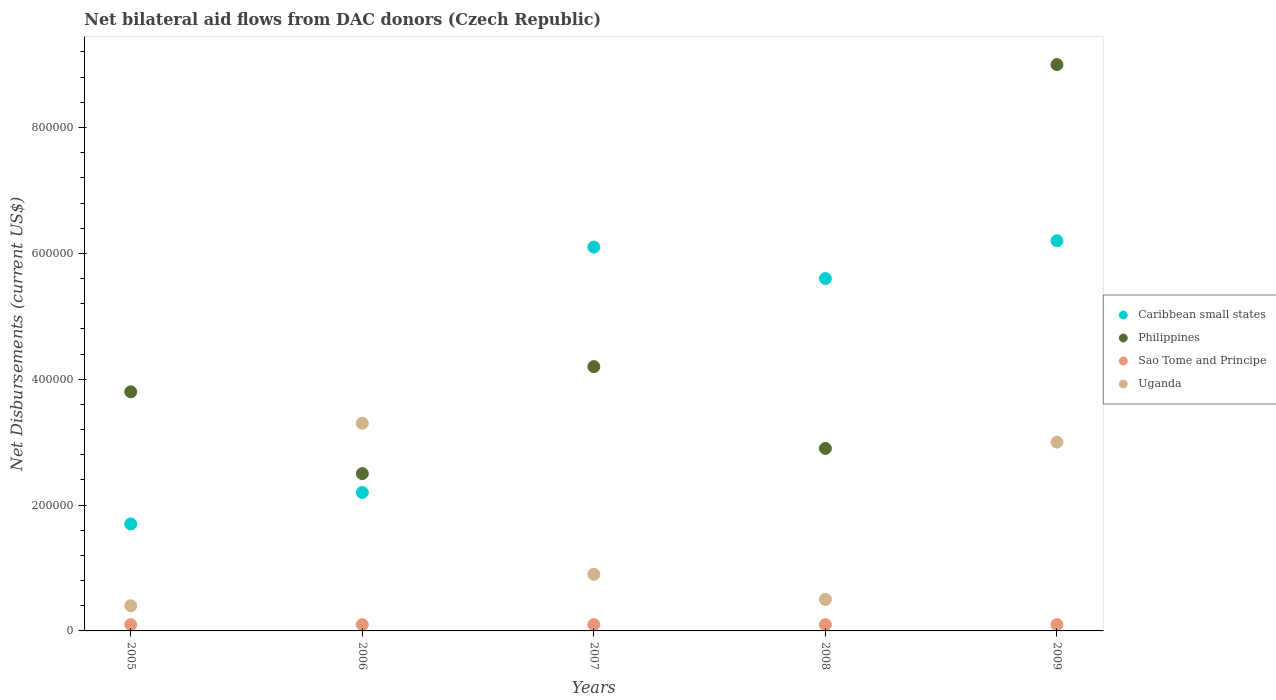How many different coloured dotlines are there?
Ensure brevity in your answer.  4. Is the number of dotlines equal to the number of legend labels?
Provide a short and direct response. Yes. What is the net bilateral aid flows in Philippines in 2008?
Ensure brevity in your answer.  2.90e+05. Across all years, what is the maximum net bilateral aid flows in Philippines?
Provide a short and direct response. 9.00e+05. Across all years, what is the minimum net bilateral aid flows in Caribbean small states?
Your response must be concise. 1.70e+05. What is the total net bilateral aid flows in Uganda in the graph?
Provide a succinct answer. 8.10e+05. What is the difference between the net bilateral aid flows in Caribbean small states in 2007 and that in 2008?
Offer a very short reply. 5.00e+04. What is the difference between the net bilateral aid flows in Philippines in 2006 and the net bilateral aid flows in Uganda in 2007?
Offer a terse response. 1.60e+05. What is the average net bilateral aid flows in Philippines per year?
Offer a terse response. 4.48e+05. Is the net bilateral aid flows in Sao Tome and Principe in 2006 less than that in 2007?
Your response must be concise. No. What is the difference between the highest and the second highest net bilateral aid flows in Sao Tome and Principe?
Your answer should be very brief. 0. What is the difference between the highest and the lowest net bilateral aid flows in Uganda?
Provide a succinct answer. 2.90e+05. Is it the case that in every year, the sum of the net bilateral aid flows in Uganda and net bilateral aid flows in Philippines  is greater than the net bilateral aid flows in Sao Tome and Principe?
Ensure brevity in your answer.  Yes. How many dotlines are there?
Provide a short and direct response. 4. How many years are there in the graph?
Provide a short and direct response. 5. What is the difference between two consecutive major ticks on the Y-axis?
Make the answer very short. 2.00e+05. Does the graph contain grids?
Your answer should be compact. No. What is the title of the graph?
Your answer should be very brief. Net bilateral aid flows from DAC donors (Czech Republic). What is the label or title of the X-axis?
Provide a succinct answer. Years. What is the label or title of the Y-axis?
Keep it short and to the point. Net Disbursements (current US$). What is the Net Disbursements (current US$) of Caribbean small states in 2005?
Give a very brief answer. 1.70e+05. What is the Net Disbursements (current US$) in Philippines in 2005?
Give a very brief answer. 3.80e+05. What is the Net Disbursements (current US$) of Sao Tome and Principe in 2005?
Ensure brevity in your answer.  10000. What is the Net Disbursements (current US$) in Uganda in 2005?
Make the answer very short. 4.00e+04. What is the Net Disbursements (current US$) in Sao Tome and Principe in 2006?
Ensure brevity in your answer.  10000. What is the Net Disbursements (current US$) of Uganda in 2007?
Provide a short and direct response. 9.00e+04. What is the Net Disbursements (current US$) in Caribbean small states in 2008?
Give a very brief answer. 5.60e+05. What is the Net Disbursements (current US$) in Sao Tome and Principe in 2008?
Ensure brevity in your answer.  10000. What is the Net Disbursements (current US$) of Uganda in 2008?
Provide a succinct answer. 5.00e+04. What is the Net Disbursements (current US$) of Caribbean small states in 2009?
Offer a very short reply. 6.20e+05. What is the Net Disbursements (current US$) of Uganda in 2009?
Your answer should be compact. 3.00e+05. Across all years, what is the maximum Net Disbursements (current US$) in Caribbean small states?
Make the answer very short. 6.20e+05. Across all years, what is the maximum Net Disbursements (current US$) in Philippines?
Keep it short and to the point. 9.00e+05. Across all years, what is the maximum Net Disbursements (current US$) in Uganda?
Make the answer very short. 3.30e+05. Across all years, what is the minimum Net Disbursements (current US$) in Sao Tome and Principe?
Keep it short and to the point. 10000. What is the total Net Disbursements (current US$) in Caribbean small states in the graph?
Ensure brevity in your answer.  2.18e+06. What is the total Net Disbursements (current US$) of Philippines in the graph?
Your response must be concise. 2.24e+06. What is the total Net Disbursements (current US$) in Sao Tome and Principe in the graph?
Offer a very short reply. 5.00e+04. What is the total Net Disbursements (current US$) of Uganda in the graph?
Give a very brief answer. 8.10e+05. What is the difference between the Net Disbursements (current US$) in Caribbean small states in 2005 and that in 2007?
Make the answer very short. -4.40e+05. What is the difference between the Net Disbursements (current US$) of Philippines in 2005 and that in 2007?
Offer a very short reply. -4.00e+04. What is the difference between the Net Disbursements (current US$) in Sao Tome and Principe in 2005 and that in 2007?
Provide a succinct answer. 0. What is the difference between the Net Disbursements (current US$) of Uganda in 2005 and that in 2007?
Offer a very short reply. -5.00e+04. What is the difference between the Net Disbursements (current US$) of Caribbean small states in 2005 and that in 2008?
Provide a short and direct response. -3.90e+05. What is the difference between the Net Disbursements (current US$) in Philippines in 2005 and that in 2008?
Your answer should be compact. 9.00e+04. What is the difference between the Net Disbursements (current US$) of Sao Tome and Principe in 2005 and that in 2008?
Provide a succinct answer. 0. What is the difference between the Net Disbursements (current US$) of Uganda in 2005 and that in 2008?
Offer a very short reply. -10000. What is the difference between the Net Disbursements (current US$) of Caribbean small states in 2005 and that in 2009?
Provide a succinct answer. -4.50e+05. What is the difference between the Net Disbursements (current US$) of Philippines in 2005 and that in 2009?
Ensure brevity in your answer.  -5.20e+05. What is the difference between the Net Disbursements (current US$) of Sao Tome and Principe in 2005 and that in 2009?
Offer a terse response. 0. What is the difference between the Net Disbursements (current US$) of Uganda in 2005 and that in 2009?
Your answer should be compact. -2.60e+05. What is the difference between the Net Disbursements (current US$) in Caribbean small states in 2006 and that in 2007?
Make the answer very short. -3.90e+05. What is the difference between the Net Disbursements (current US$) of Philippines in 2006 and that in 2007?
Your response must be concise. -1.70e+05. What is the difference between the Net Disbursements (current US$) of Uganda in 2006 and that in 2007?
Your answer should be very brief. 2.40e+05. What is the difference between the Net Disbursements (current US$) of Philippines in 2006 and that in 2008?
Offer a terse response. -4.00e+04. What is the difference between the Net Disbursements (current US$) of Sao Tome and Principe in 2006 and that in 2008?
Provide a succinct answer. 0. What is the difference between the Net Disbursements (current US$) of Caribbean small states in 2006 and that in 2009?
Keep it short and to the point. -4.00e+05. What is the difference between the Net Disbursements (current US$) of Philippines in 2006 and that in 2009?
Keep it short and to the point. -6.50e+05. What is the difference between the Net Disbursements (current US$) of Philippines in 2007 and that in 2008?
Keep it short and to the point. 1.30e+05. What is the difference between the Net Disbursements (current US$) in Sao Tome and Principe in 2007 and that in 2008?
Provide a succinct answer. 0. What is the difference between the Net Disbursements (current US$) in Uganda in 2007 and that in 2008?
Ensure brevity in your answer.  4.00e+04. What is the difference between the Net Disbursements (current US$) of Philippines in 2007 and that in 2009?
Make the answer very short. -4.80e+05. What is the difference between the Net Disbursements (current US$) in Sao Tome and Principe in 2007 and that in 2009?
Give a very brief answer. 0. What is the difference between the Net Disbursements (current US$) of Philippines in 2008 and that in 2009?
Give a very brief answer. -6.10e+05. What is the difference between the Net Disbursements (current US$) in Sao Tome and Principe in 2008 and that in 2009?
Your answer should be compact. 0. What is the difference between the Net Disbursements (current US$) of Caribbean small states in 2005 and the Net Disbursements (current US$) of Sao Tome and Principe in 2006?
Your answer should be very brief. 1.60e+05. What is the difference between the Net Disbursements (current US$) in Caribbean small states in 2005 and the Net Disbursements (current US$) in Uganda in 2006?
Keep it short and to the point. -1.60e+05. What is the difference between the Net Disbursements (current US$) of Sao Tome and Principe in 2005 and the Net Disbursements (current US$) of Uganda in 2006?
Offer a terse response. -3.20e+05. What is the difference between the Net Disbursements (current US$) of Caribbean small states in 2005 and the Net Disbursements (current US$) of Philippines in 2007?
Your response must be concise. -2.50e+05. What is the difference between the Net Disbursements (current US$) in Philippines in 2005 and the Net Disbursements (current US$) in Uganda in 2007?
Your answer should be compact. 2.90e+05. What is the difference between the Net Disbursements (current US$) in Caribbean small states in 2005 and the Net Disbursements (current US$) in Philippines in 2008?
Provide a succinct answer. -1.20e+05. What is the difference between the Net Disbursements (current US$) of Caribbean small states in 2005 and the Net Disbursements (current US$) of Sao Tome and Principe in 2008?
Provide a succinct answer. 1.60e+05. What is the difference between the Net Disbursements (current US$) in Philippines in 2005 and the Net Disbursements (current US$) in Sao Tome and Principe in 2008?
Offer a terse response. 3.70e+05. What is the difference between the Net Disbursements (current US$) of Philippines in 2005 and the Net Disbursements (current US$) of Uganda in 2008?
Give a very brief answer. 3.30e+05. What is the difference between the Net Disbursements (current US$) in Sao Tome and Principe in 2005 and the Net Disbursements (current US$) in Uganda in 2008?
Offer a very short reply. -4.00e+04. What is the difference between the Net Disbursements (current US$) in Caribbean small states in 2005 and the Net Disbursements (current US$) in Philippines in 2009?
Your answer should be very brief. -7.30e+05. What is the difference between the Net Disbursements (current US$) of Sao Tome and Principe in 2005 and the Net Disbursements (current US$) of Uganda in 2009?
Your response must be concise. -2.90e+05. What is the difference between the Net Disbursements (current US$) of Caribbean small states in 2006 and the Net Disbursements (current US$) of Philippines in 2007?
Offer a terse response. -2.00e+05. What is the difference between the Net Disbursements (current US$) in Caribbean small states in 2006 and the Net Disbursements (current US$) in Sao Tome and Principe in 2007?
Your answer should be very brief. 2.10e+05. What is the difference between the Net Disbursements (current US$) of Caribbean small states in 2006 and the Net Disbursements (current US$) of Uganda in 2007?
Provide a succinct answer. 1.30e+05. What is the difference between the Net Disbursements (current US$) in Philippines in 2006 and the Net Disbursements (current US$) in Sao Tome and Principe in 2007?
Provide a short and direct response. 2.40e+05. What is the difference between the Net Disbursements (current US$) in Philippines in 2006 and the Net Disbursements (current US$) in Uganda in 2007?
Your answer should be very brief. 1.60e+05. What is the difference between the Net Disbursements (current US$) in Caribbean small states in 2006 and the Net Disbursements (current US$) in Philippines in 2008?
Offer a very short reply. -7.00e+04. What is the difference between the Net Disbursements (current US$) in Caribbean small states in 2006 and the Net Disbursements (current US$) in Sao Tome and Principe in 2008?
Make the answer very short. 2.10e+05. What is the difference between the Net Disbursements (current US$) in Philippines in 2006 and the Net Disbursements (current US$) in Uganda in 2008?
Your answer should be compact. 2.00e+05. What is the difference between the Net Disbursements (current US$) in Sao Tome and Principe in 2006 and the Net Disbursements (current US$) in Uganda in 2008?
Provide a succinct answer. -4.00e+04. What is the difference between the Net Disbursements (current US$) in Caribbean small states in 2006 and the Net Disbursements (current US$) in Philippines in 2009?
Give a very brief answer. -6.80e+05. What is the difference between the Net Disbursements (current US$) in Philippines in 2006 and the Net Disbursements (current US$) in Sao Tome and Principe in 2009?
Your answer should be compact. 2.40e+05. What is the difference between the Net Disbursements (current US$) of Caribbean small states in 2007 and the Net Disbursements (current US$) of Sao Tome and Principe in 2008?
Your answer should be compact. 6.00e+05. What is the difference between the Net Disbursements (current US$) of Caribbean small states in 2007 and the Net Disbursements (current US$) of Uganda in 2008?
Keep it short and to the point. 5.60e+05. What is the difference between the Net Disbursements (current US$) in Caribbean small states in 2007 and the Net Disbursements (current US$) in Philippines in 2009?
Keep it short and to the point. -2.90e+05. What is the difference between the Net Disbursements (current US$) in Caribbean small states in 2007 and the Net Disbursements (current US$) in Sao Tome and Principe in 2009?
Your response must be concise. 6.00e+05. What is the difference between the Net Disbursements (current US$) in Philippines in 2007 and the Net Disbursements (current US$) in Sao Tome and Principe in 2009?
Make the answer very short. 4.10e+05. What is the difference between the Net Disbursements (current US$) of Caribbean small states in 2008 and the Net Disbursements (current US$) of Philippines in 2009?
Your response must be concise. -3.40e+05. What is the difference between the Net Disbursements (current US$) of Caribbean small states in 2008 and the Net Disbursements (current US$) of Sao Tome and Principe in 2009?
Offer a terse response. 5.50e+05. What is the difference between the Net Disbursements (current US$) of Caribbean small states in 2008 and the Net Disbursements (current US$) of Uganda in 2009?
Your answer should be compact. 2.60e+05. What is the difference between the Net Disbursements (current US$) of Philippines in 2008 and the Net Disbursements (current US$) of Uganda in 2009?
Keep it short and to the point. -10000. What is the average Net Disbursements (current US$) of Caribbean small states per year?
Your answer should be compact. 4.36e+05. What is the average Net Disbursements (current US$) in Philippines per year?
Your response must be concise. 4.48e+05. What is the average Net Disbursements (current US$) in Uganda per year?
Make the answer very short. 1.62e+05. In the year 2005, what is the difference between the Net Disbursements (current US$) of Caribbean small states and Net Disbursements (current US$) of Philippines?
Your answer should be compact. -2.10e+05. In the year 2005, what is the difference between the Net Disbursements (current US$) in Sao Tome and Principe and Net Disbursements (current US$) in Uganda?
Offer a terse response. -3.00e+04. In the year 2006, what is the difference between the Net Disbursements (current US$) in Caribbean small states and Net Disbursements (current US$) in Sao Tome and Principe?
Give a very brief answer. 2.10e+05. In the year 2006, what is the difference between the Net Disbursements (current US$) of Philippines and Net Disbursements (current US$) of Sao Tome and Principe?
Provide a short and direct response. 2.40e+05. In the year 2006, what is the difference between the Net Disbursements (current US$) in Sao Tome and Principe and Net Disbursements (current US$) in Uganda?
Your response must be concise. -3.20e+05. In the year 2007, what is the difference between the Net Disbursements (current US$) of Caribbean small states and Net Disbursements (current US$) of Uganda?
Provide a short and direct response. 5.20e+05. In the year 2007, what is the difference between the Net Disbursements (current US$) in Philippines and Net Disbursements (current US$) in Sao Tome and Principe?
Ensure brevity in your answer.  4.10e+05. In the year 2007, what is the difference between the Net Disbursements (current US$) in Philippines and Net Disbursements (current US$) in Uganda?
Provide a succinct answer. 3.30e+05. In the year 2007, what is the difference between the Net Disbursements (current US$) in Sao Tome and Principe and Net Disbursements (current US$) in Uganda?
Your response must be concise. -8.00e+04. In the year 2008, what is the difference between the Net Disbursements (current US$) in Caribbean small states and Net Disbursements (current US$) in Philippines?
Give a very brief answer. 2.70e+05. In the year 2008, what is the difference between the Net Disbursements (current US$) in Caribbean small states and Net Disbursements (current US$) in Uganda?
Your response must be concise. 5.10e+05. In the year 2008, what is the difference between the Net Disbursements (current US$) of Philippines and Net Disbursements (current US$) of Uganda?
Provide a short and direct response. 2.40e+05. In the year 2008, what is the difference between the Net Disbursements (current US$) of Sao Tome and Principe and Net Disbursements (current US$) of Uganda?
Your answer should be compact. -4.00e+04. In the year 2009, what is the difference between the Net Disbursements (current US$) of Caribbean small states and Net Disbursements (current US$) of Philippines?
Provide a short and direct response. -2.80e+05. In the year 2009, what is the difference between the Net Disbursements (current US$) in Caribbean small states and Net Disbursements (current US$) in Sao Tome and Principe?
Offer a very short reply. 6.10e+05. In the year 2009, what is the difference between the Net Disbursements (current US$) in Philippines and Net Disbursements (current US$) in Sao Tome and Principe?
Ensure brevity in your answer.  8.90e+05. In the year 2009, what is the difference between the Net Disbursements (current US$) of Sao Tome and Principe and Net Disbursements (current US$) of Uganda?
Keep it short and to the point. -2.90e+05. What is the ratio of the Net Disbursements (current US$) in Caribbean small states in 2005 to that in 2006?
Your response must be concise. 0.77. What is the ratio of the Net Disbursements (current US$) of Philippines in 2005 to that in 2006?
Your answer should be compact. 1.52. What is the ratio of the Net Disbursements (current US$) in Uganda in 2005 to that in 2006?
Keep it short and to the point. 0.12. What is the ratio of the Net Disbursements (current US$) of Caribbean small states in 2005 to that in 2007?
Ensure brevity in your answer.  0.28. What is the ratio of the Net Disbursements (current US$) in Philippines in 2005 to that in 2007?
Your answer should be compact. 0.9. What is the ratio of the Net Disbursements (current US$) of Sao Tome and Principe in 2005 to that in 2007?
Your response must be concise. 1. What is the ratio of the Net Disbursements (current US$) of Uganda in 2005 to that in 2007?
Give a very brief answer. 0.44. What is the ratio of the Net Disbursements (current US$) in Caribbean small states in 2005 to that in 2008?
Provide a succinct answer. 0.3. What is the ratio of the Net Disbursements (current US$) in Philippines in 2005 to that in 2008?
Give a very brief answer. 1.31. What is the ratio of the Net Disbursements (current US$) in Sao Tome and Principe in 2005 to that in 2008?
Your response must be concise. 1. What is the ratio of the Net Disbursements (current US$) in Uganda in 2005 to that in 2008?
Make the answer very short. 0.8. What is the ratio of the Net Disbursements (current US$) of Caribbean small states in 2005 to that in 2009?
Your answer should be compact. 0.27. What is the ratio of the Net Disbursements (current US$) of Philippines in 2005 to that in 2009?
Provide a short and direct response. 0.42. What is the ratio of the Net Disbursements (current US$) of Sao Tome and Principe in 2005 to that in 2009?
Offer a very short reply. 1. What is the ratio of the Net Disbursements (current US$) in Uganda in 2005 to that in 2009?
Offer a terse response. 0.13. What is the ratio of the Net Disbursements (current US$) of Caribbean small states in 2006 to that in 2007?
Your answer should be compact. 0.36. What is the ratio of the Net Disbursements (current US$) of Philippines in 2006 to that in 2007?
Your response must be concise. 0.6. What is the ratio of the Net Disbursements (current US$) of Sao Tome and Principe in 2006 to that in 2007?
Keep it short and to the point. 1. What is the ratio of the Net Disbursements (current US$) of Uganda in 2006 to that in 2007?
Offer a very short reply. 3.67. What is the ratio of the Net Disbursements (current US$) of Caribbean small states in 2006 to that in 2008?
Keep it short and to the point. 0.39. What is the ratio of the Net Disbursements (current US$) in Philippines in 2006 to that in 2008?
Provide a short and direct response. 0.86. What is the ratio of the Net Disbursements (current US$) in Sao Tome and Principe in 2006 to that in 2008?
Ensure brevity in your answer.  1. What is the ratio of the Net Disbursements (current US$) in Caribbean small states in 2006 to that in 2009?
Provide a short and direct response. 0.35. What is the ratio of the Net Disbursements (current US$) of Philippines in 2006 to that in 2009?
Provide a succinct answer. 0.28. What is the ratio of the Net Disbursements (current US$) in Sao Tome and Principe in 2006 to that in 2009?
Ensure brevity in your answer.  1. What is the ratio of the Net Disbursements (current US$) in Uganda in 2006 to that in 2009?
Your answer should be very brief. 1.1. What is the ratio of the Net Disbursements (current US$) of Caribbean small states in 2007 to that in 2008?
Provide a short and direct response. 1.09. What is the ratio of the Net Disbursements (current US$) in Philippines in 2007 to that in 2008?
Ensure brevity in your answer.  1.45. What is the ratio of the Net Disbursements (current US$) in Sao Tome and Principe in 2007 to that in 2008?
Offer a very short reply. 1. What is the ratio of the Net Disbursements (current US$) of Caribbean small states in 2007 to that in 2009?
Make the answer very short. 0.98. What is the ratio of the Net Disbursements (current US$) in Philippines in 2007 to that in 2009?
Ensure brevity in your answer.  0.47. What is the ratio of the Net Disbursements (current US$) of Sao Tome and Principe in 2007 to that in 2009?
Provide a short and direct response. 1. What is the ratio of the Net Disbursements (current US$) in Caribbean small states in 2008 to that in 2009?
Ensure brevity in your answer.  0.9. What is the ratio of the Net Disbursements (current US$) in Philippines in 2008 to that in 2009?
Provide a short and direct response. 0.32. What is the ratio of the Net Disbursements (current US$) in Sao Tome and Principe in 2008 to that in 2009?
Keep it short and to the point. 1. What is the ratio of the Net Disbursements (current US$) of Uganda in 2008 to that in 2009?
Provide a short and direct response. 0.17. What is the difference between the highest and the lowest Net Disbursements (current US$) in Caribbean small states?
Your answer should be compact. 4.50e+05. What is the difference between the highest and the lowest Net Disbursements (current US$) in Philippines?
Make the answer very short. 6.50e+05. What is the difference between the highest and the lowest Net Disbursements (current US$) of Sao Tome and Principe?
Make the answer very short. 0. What is the difference between the highest and the lowest Net Disbursements (current US$) in Uganda?
Keep it short and to the point. 2.90e+05. 